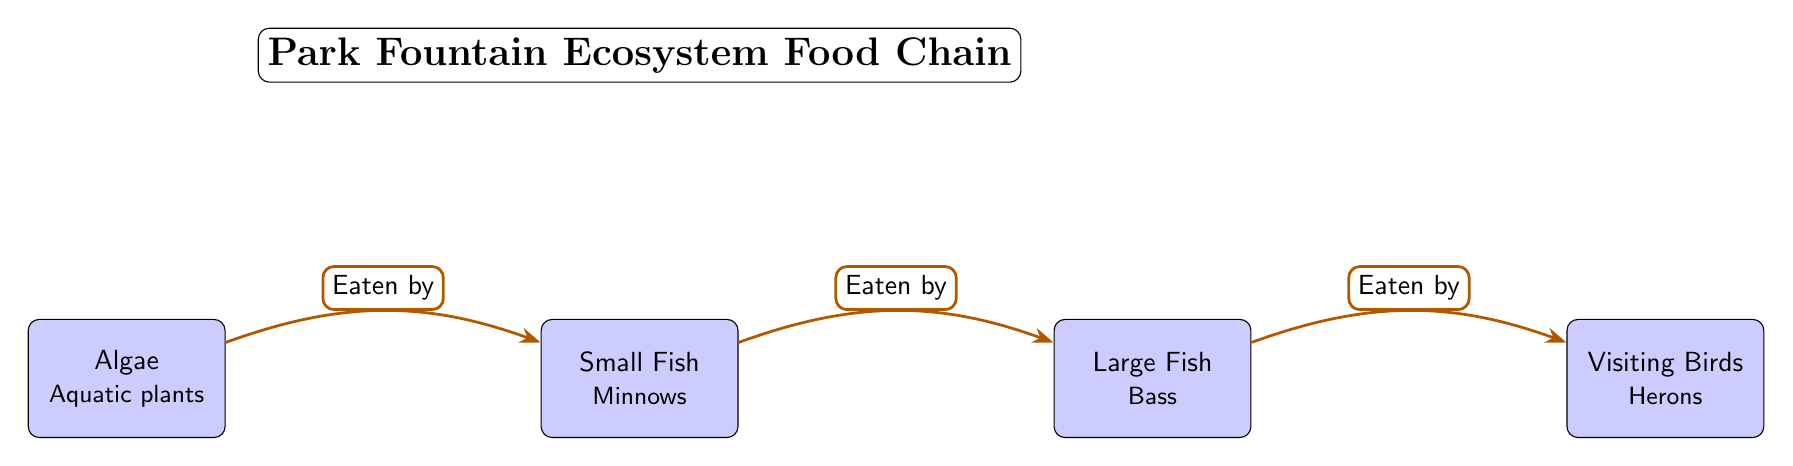What is the first organism in the food chain? The diagram shows that the first organism at the leftmost node is labeled "Algae." It is the starting point of the food chain and the primary producer in this ecosystem.
Answer: Algae How many organisms are present in the food chain? By counting the nodes listed in the diagram, we find four organisms: Algae, Small Fish, Large Fish, and Visiting Birds. Thus, the total is four.
Answer: 4 Which organism is eaten by Large Fish? The diagram indicates that the arrow pointing towards Large Fish specifies that it is "Eaten by" Small Fish. Therefore, Small Fish is the organism that Large Fish consumes.
Answer: Small Fish What is the role of the Visiting Birds in this ecosystem? The diagram labels the Visiting Birds as the top predator in this food chain, as indicated by the arrow that points towards them from Large Fish. This shows they are at the end of the food chain and primarily rely on Large Fish for food.
Answer: Top predator Which organism consumes Algae? Referring to the arrow directed from Algae to Small Fish, it is clear that Small Fish consumes Algae as part of the food chain process.
Answer: Small Fish What type of fish is considered Large Fish in this food chain? The diagram specifies that Large Fish refers to "Bass." Hence, it represents this particular species within the ecosystem.
Answer: Bass Follow the flow: who eats whom starting from Algae? Starting from Algae, Small Fish eats Algae; then Large Fish eats Small Fish, and finally, Visiting Birds eat Large Fish. This order reveals the chain of consumption in this ecosystem.
Answer: Algae -> Small Fish -> Large Fish -> Visiting Birds What type of relationship exists between Small Fish and Large Fish? The relationship is predatory; Small Fish is prey to Large Fish, which is shown by the directional arrow indicating "Eaten by." This signifies a clear food chain interaction.
Answer: Predatory Which part of the diagram explains the primary producer? The primary producer is defined by the leftmost node labeled Algae, demonstrating its role as the foundation of the food chain.
Answer: Algae 